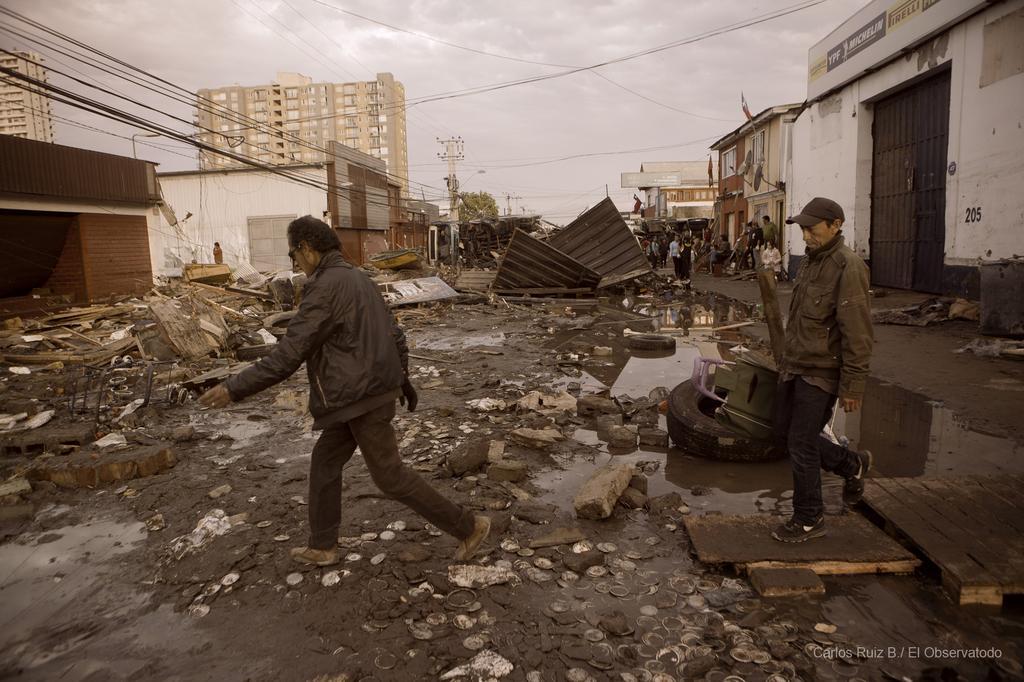How would you summarize this image in a sentence or two? In the image in the center we can see two people were walking and they were holding some objects. In the background we can see the sky,clouds,wires,buildings,trees,poles,waste items and few people were standing. 